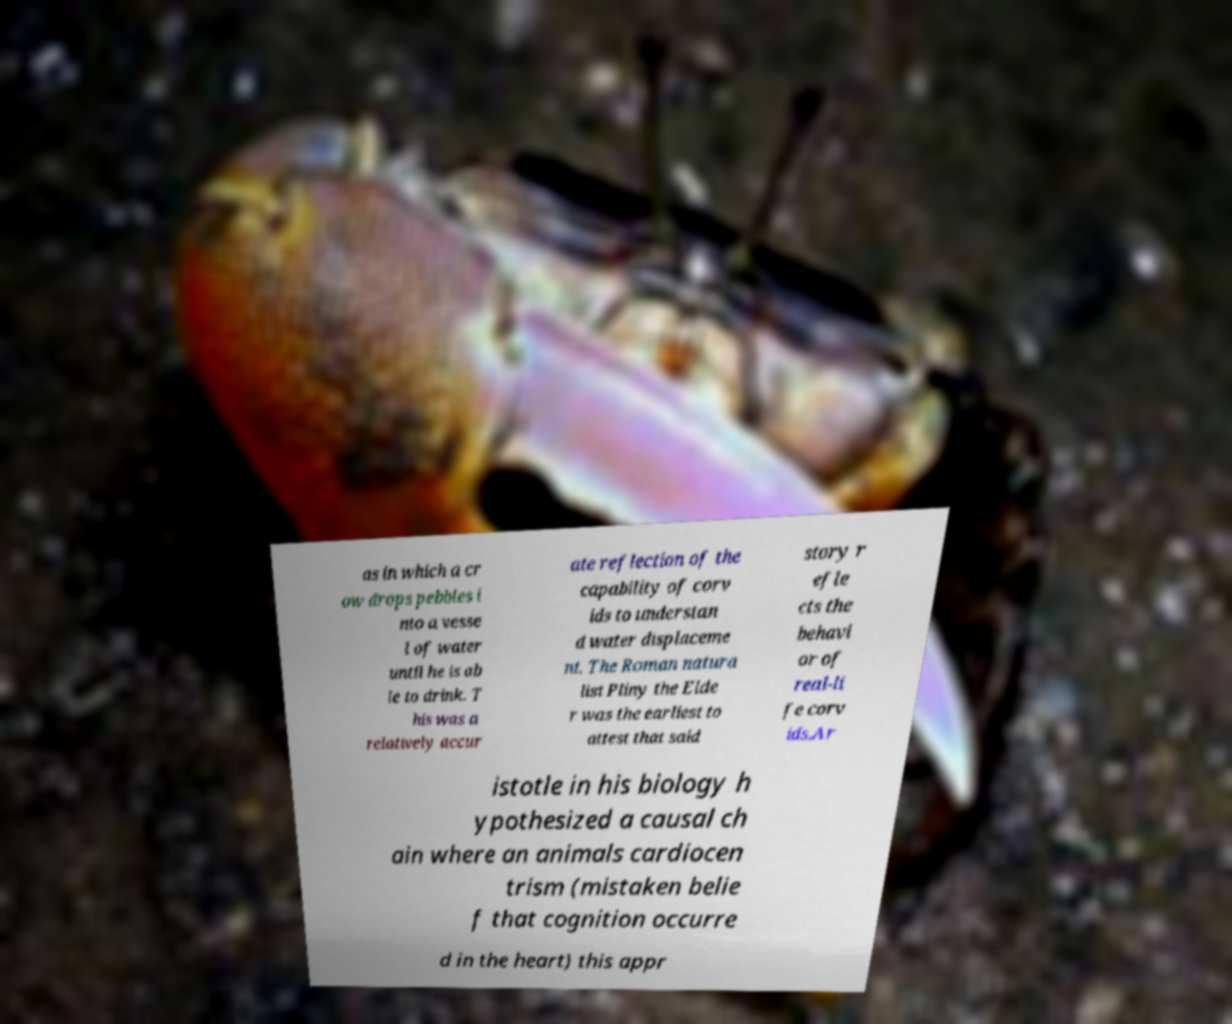Could you extract and type out the text from this image? as in which a cr ow drops pebbles i nto a vesse l of water until he is ab le to drink. T his was a relatively accur ate reflection of the capability of corv ids to understan d water displaceme nt. The Roman natura list Pliny the Elde r was the earliest to attest that said story r efle cts the behavi or of real-li fe corv ids.Ar istotle in his biology h ypothesized a causal ch ain where an animals cardiocen trism (mistaken belie f that cognition occurre d in the heart) this appr 